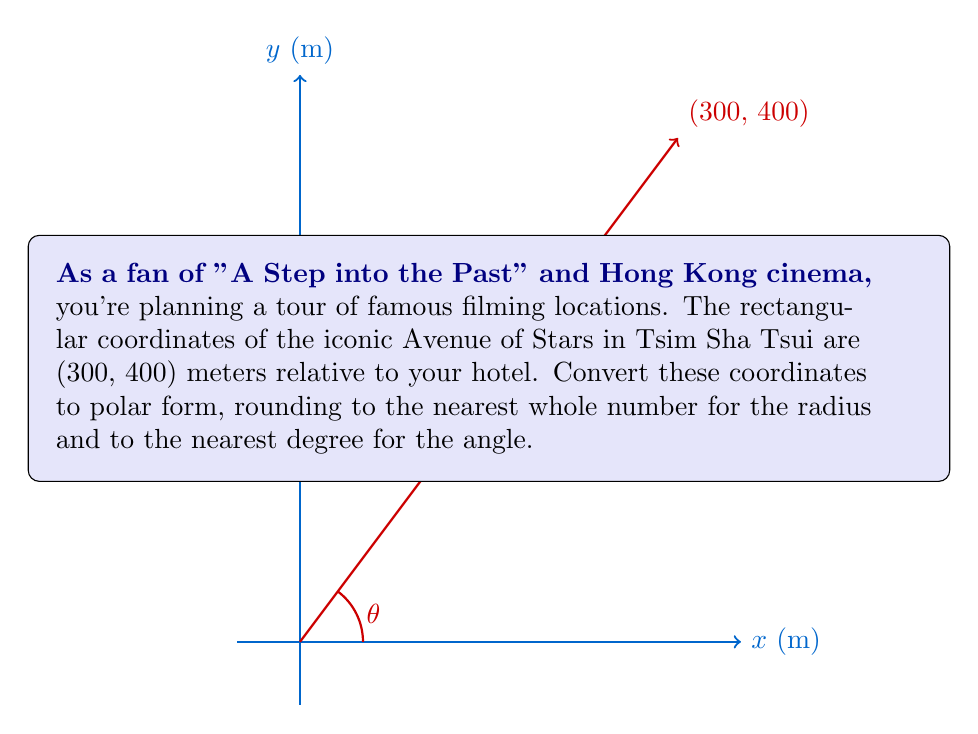Could you help me with this problem? To convert rectangular coordinates $(x, y)$ to polar coordinates $(r, \theta)$, we use the following formulas:

1. $r = \sqrt{x^2 + y^2}$
2. $\theta = \tan^{-1}(\frac{y}{x})$

For the given point (300, 400):

1. Calculate $r$:
   $$r = \sqrt{300^2 + 400^2} = \sqrt{90,000 + 160,000} = \sqrt{250,000} = 500$$

2. Calculate $\theta$:
   $$\theta = \tan^{-1}(\frac{400}{300}) = \tan^{-1}(\frac{4}{3}) \approx 53.13^\circ$$

3. Round the results:
   $r$ rounded to the nearest whole number: 500
   $\theta$ rounded to the nearest degree: 53°

Therefore, the polar coordinates are $(500, 53°)$.

Note: The angle is measured counterclockwise from the positive x-axis, which is standard in mathematics and physics.
Answer: $(500, 53°)$ 